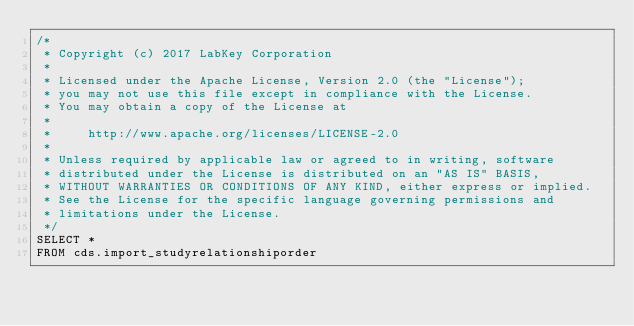<code> <loc_0><loc_0><loc_500><loc_500><_SQL_>/*
 * Copyright (c) 2017 LabKey Corporation
 *
 * Licensed under the Apache License, Version 2.0 (the "License");
 * you may not use this file except in compliance with the License.
 * You may obtain a copy of the License at
 *
 *     http://www.apache.org/licenses/LICENSE-2.0
 *
 * Unless required by applicable law or agreed to in writing, software
 * distributed under the License is distributed on an "AS IS" BASIS,
 * WITHOUT WARRANTIES OR CONDITIONS OF ANY KIND, either express or implied.
 * See the License for the specific language governing permissions and
 * limitations under the License.
 */
SELECT *
FROM cds.import_studyrelationshiporder</code> 